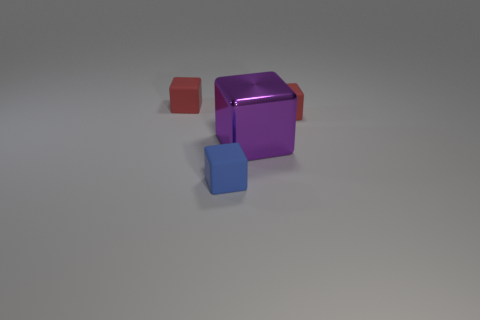Is the small blue matte thing the same shape as the purple thing?
Your answer should be compact. Yes. The rubber block that is right of the purple block is what color?
Provide a succinct answer. Red. Is there a red cube behind the tiny red thing to the right of the small red matte object on the left side of the big purple thing?
Make the answer very short. Yes. Is the number of tiny rubber things that are on the right side of the blue rubber cube greater than the number of large brown metal cylinders?
Your response must be concise. Yes. Is the shape of the tiny rubber object that is on the right side of the blue object the same as  the purple object?
Your answer should be compact. Yes. Are there any other things that are the same material as the large cube?
Make the answer very short. No. What number of objects are either purple things or red matte objects left of the blue matte thing?
Keep it short and to the point. 2. How big is the cube that is both on the right side of the small blue matte thing and behind the big purple shiny object?
Provide a short and direct response. Small. Are there more red blocks that are in front of the big purple cube than red things in front of the blue object?
Your answer should be compact. No. There is a blue object; is its shape the same as the small red matte thing that is on the left side of the small blue block?
Your response must be concise. Yes. 